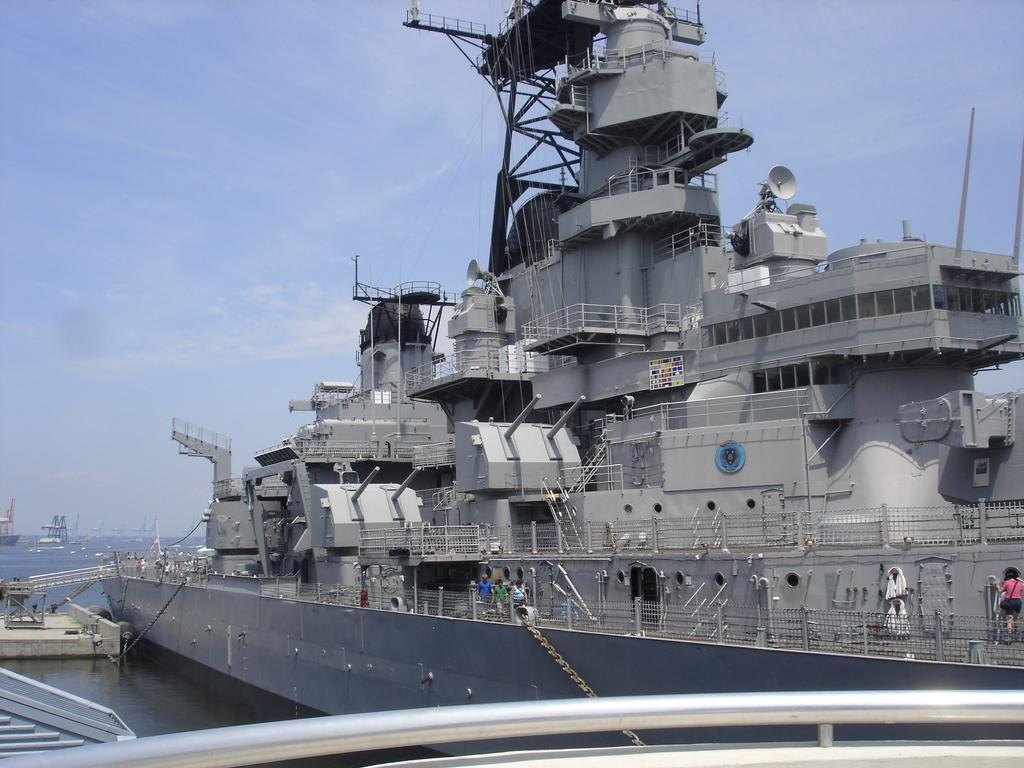What is the main subject of the image? The main subject of the image is a ship. What are the people in the image doing? The people in the image are walking on the ship. What can be seen in the background of the image? There is sea and sky visible in the image. What type of zinc is being used to build the throne on the ship? There is no throne present on the ship in the image, and therefore no zinc is being used for its construction. 